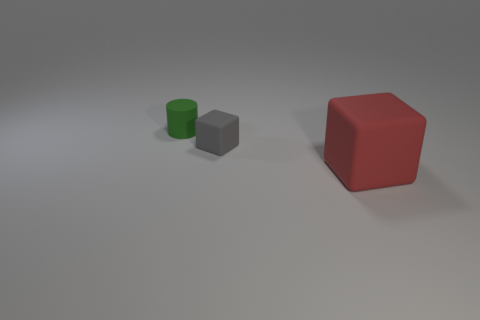How many other objects are there of the same material as the large cube?
Offer a terse response. 2. There is a matte object that is both right of the green cylinder and behind the big red matte cube; what shape is it?
Keep it short and to the point. Cube. There is a big thing that is made of the same material as the small gray cube; what color is it?
Provide a succinct answer. Red. Are there an equal number of gray matte objects to the left of the green matte object and matte objects?
Offer a very short reply. No. There is a gray object that is the same size as the green rubber object; what shape is it?
Provide a succinct answer. Cube. What number of other things are there of the same shape as the tiny gray rubber thing?
Your response must be concise. 1. Does the red cube have the same size as the matte block to the left of the big thing?
Your answer should be compact. No. What number of things are objects in front of the tiny cylinder or green cylinders?
Ensure brevity in your answer.  3. What is the shape of the tiny object that is right of the tiny green rubber cylinder?
Your answer should be compact. Cube. Are there the same number of small rubber objects behind the gray rubber thing and small rubber objects that are on the right side of the big red block?
Offer a very short reply. No. 